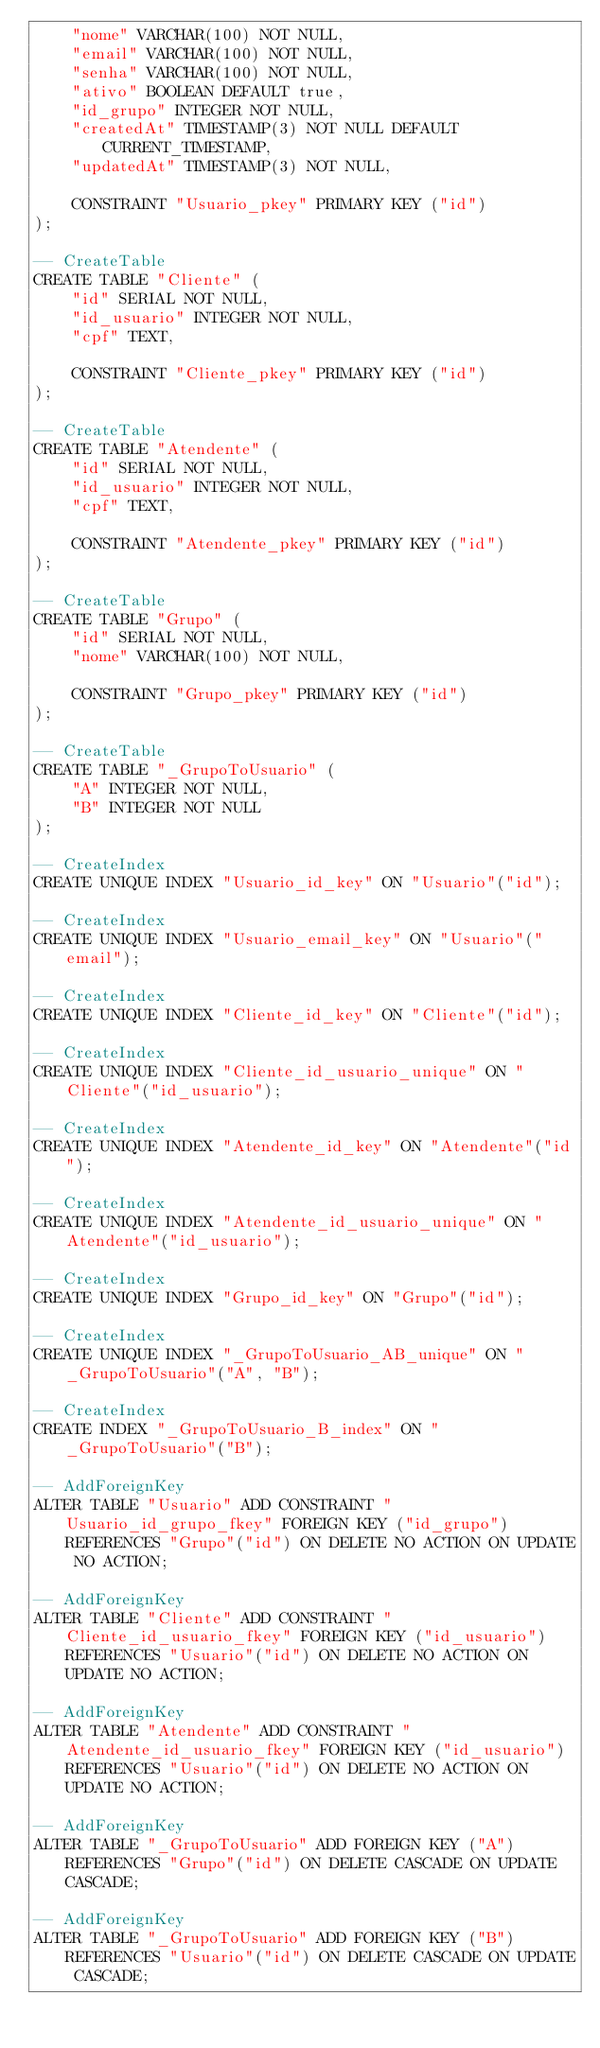<code> <loc_0><loc_0><loc_500><loc_500><_SQL_>    "nome" VARCHAR(100) NOT NULL,
    "email" VARCHAR(100) NOT NULL,
    "senha" VARCHAR(100) NOT NULL,
    "ativo" BOOLEAN DEFAULT true,
    "id_grupo" INTEGER NOT NULL,
    "createdAt" TIMESTAMP(3) NOT NULL DEFAULT CURRENT_TIMESTAMP,
    "updatedAt" TIMESTAMP(3) NOT NULL,

    CONSTRAINT "Usuario_pkey" PRIMARY KEY ("id")
);

-- CreateTable
CREATE TABLE "Cliente" (
    "id" SERIAL NOT NULL,
    "id_usuario" INTEGER NOT NULL,
    "cpf" TEXT,

    CONSTRAINT "Cliente_pkey" PRIMARY KEY ("id")
);

-- CreateTable
CREATE TABLE "Atendente" (
    "id" SERIAL NOT NULL,
    "id_usuario" INTEGER NOT NULL,
    "cpf" TEXT,

    CONSTRAINT "Atendente_pkey" PRIMARY KEY ("id")
);

-- CreateTable
CREATE TABLE "Grupo" (
    "id" SERIAL NOT NULL,
    "nome" VARCHAR(100) NOT NULL,

    CONSTRAINT "Grupo_pkey" PRIMARY KEY ("id")
);

-- CreateTable
CREATE TABLE "_GrupoToUsuario" (
    "A" INTEGER NOT NULL,
    "B" INTEGER NOT NULL
);

-- CreateIndex
CREATE UNIQUE INDEX "Usuario_id_key" ON "Usuario"("id");

-- CreateIndex
CREATE UNIQUE INDEX "Usuario_email_key" ON "Usuario"("email");

-- CreateIndex
CREATE UNIQUE INDEX "Cliente_id_key" ON "Cliente"("id");

-- CreateIndex
CREATE UNIQUE INDEX "Cliente_id_usuario_unique" ON "Cliente"("id_usuario");

-- CreateIndex
CREATE UNIQUE INDEX "Atendente_id_key" ON "Atendente"("id");

-- CreateIndex
CREATE UNIQUE INDEX "Atendente_id_usuario_unique" ON "Atendente"("id_usuario");

-- CreateIndex
CREATE UNIQUE INDEX "Grupo_id_key" ON "Grupo"("id");

-- CreateIndex
CREATE UNIQUE INDEX "_GrupoToUsuario_AB_unique" ON "_GrupoToUsuario"("A", "B");

-- CreateIndex
CREATE INDEX "_GrupoToUsuario_B_index" ON "_GrupoToUsuario"("B");

-- AddForeignKey
ALTER TABLE "Usuario" ADD CONSTRAINT "Usuario_id_grupo_fkey" FOREIGN KEY ("id_grupo") REFERENCES "Grupo"("id") ON DELETE NO ACTION ON UPDATE NO ACTION;

-- AddForeignKey
ALTER TABLE "Cliente" ADD CONSTRAINT "Cliente_id_usuario_fkey" FOREIGN KEY ("id_usuario") REFERENCES "Usuario"("id") ON DELETE NO ACTION ON UPDATE NO ACTION;

-- AddForeignKey
ALTER TABLE "Atendente" ADD CONSTRAINT "Atendente_id_usuario_fkey" FOREIGN KEY ("id_usuario") REFERENCES "Usuario"("id") ON DELETE NO ACTION ON UPDATE NO ACTION;

-- AddForeignKey
ALTER TABLE "_GrupoToUsuario" ADD FOREIGN KEY ("A") REFERENCES "Grupo"("id") ON DELETE CASCADE ON UPDATE CASCADE;

-- AddForeignKey
ALTER TABLE "_GrupoToUsuario" ADD FOREIGN KEY ("B") REFERENCES "Usuario"("id") ON DELETE CASCADE ON UPDATE CASCADE;
</code> 